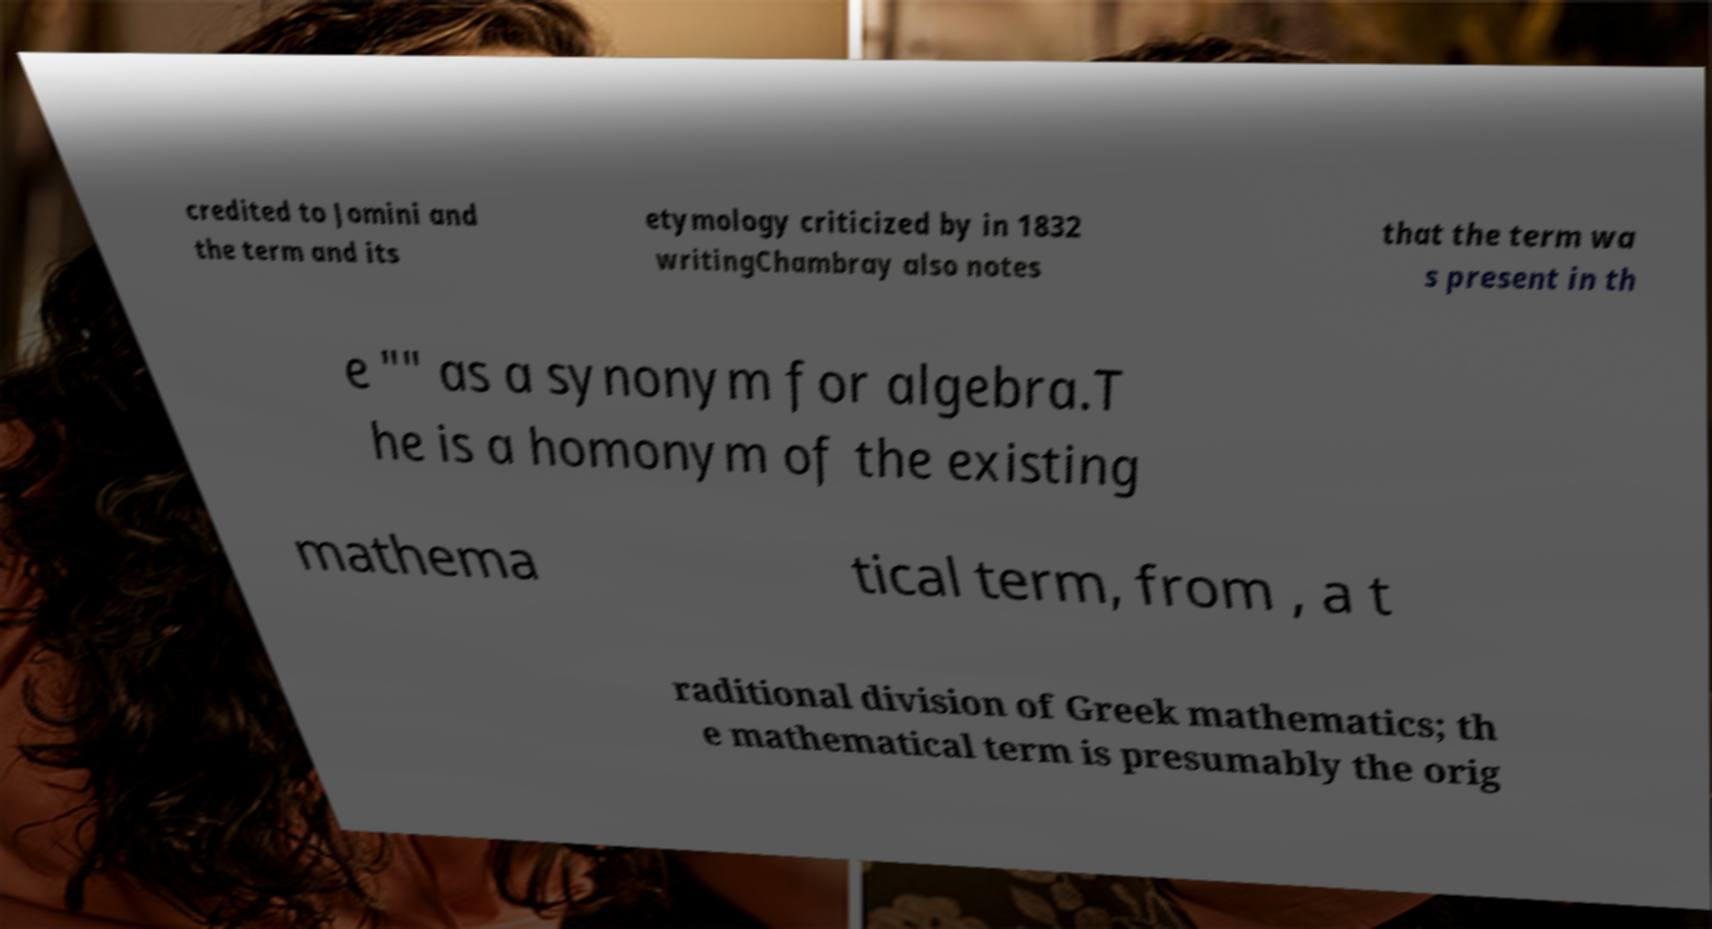For documentation purposes, I need the text within this image transcribed. Could you provide that? credited to Jomini and the term and its etymology criticized by in 1832 writingChambray also notes that the term wa s present in th e "" as a synonym for algebra.T he is a homonym of the existing mathema tical term, from , a t raditional division of Greek mathematics; th e mathematical term is presumably the orig 